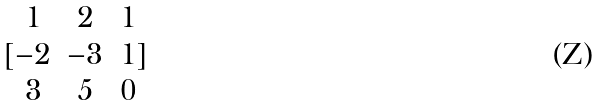Convert formula to latex. <formula><loc_0><loc_0><loc_500><loc_500>[ \begin{matrix} 1 & 2 & 1 \\ - 2 & - 3 & 1 \\ 3 & 5 & 0 \end{matrix} ]</formula> 